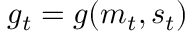Convert formula to latex. <formula><loc_0><loc_0><loc_500><loc_500>g _ { t } = g ( m _ { t } , s _ { t } )</formula> 